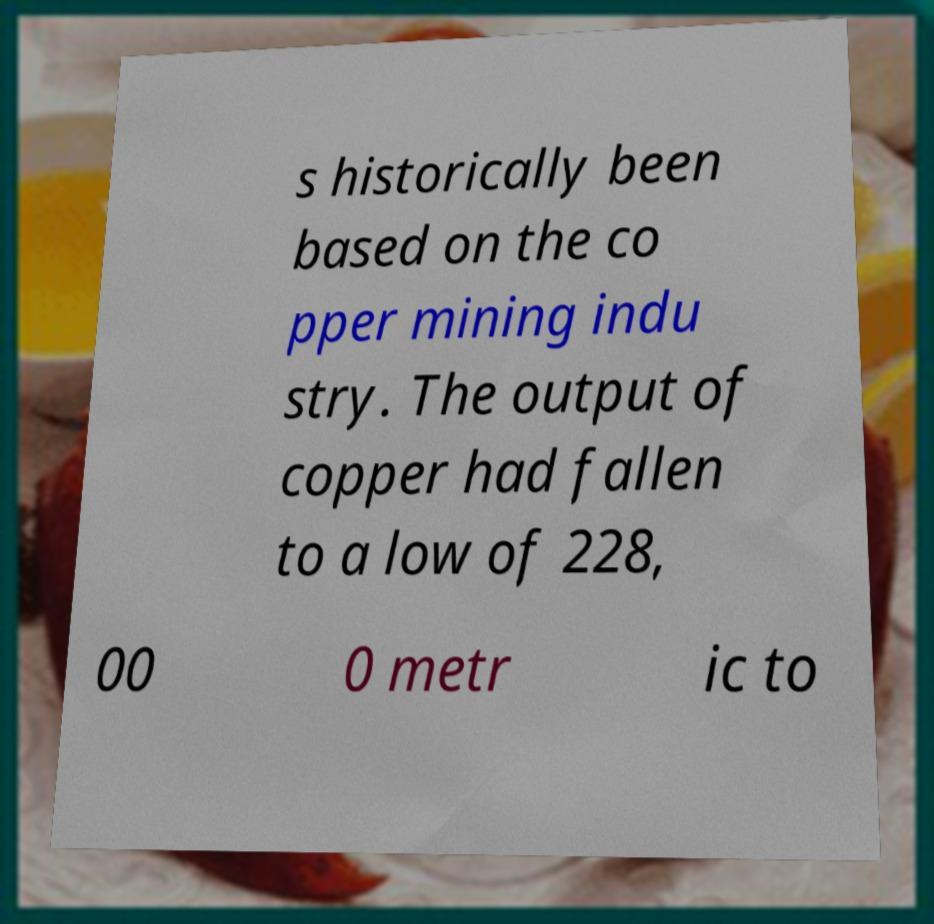There's text embedded in this image that I need extracted. Can you transcribe it verbatim? s historically been based on the co pper mining indu stry. The output of copper had fallen to a low of 228, 00 0 metr ic to 